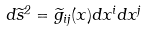Convert formula to latex. <formula><loc_0><loc_0><loc_500><loc_500>d \widetilde { s } ^ { 2 } = \widetilde { g } _ { i j } ( x ) d x ^ { i } d x ^ { j }</formula> 